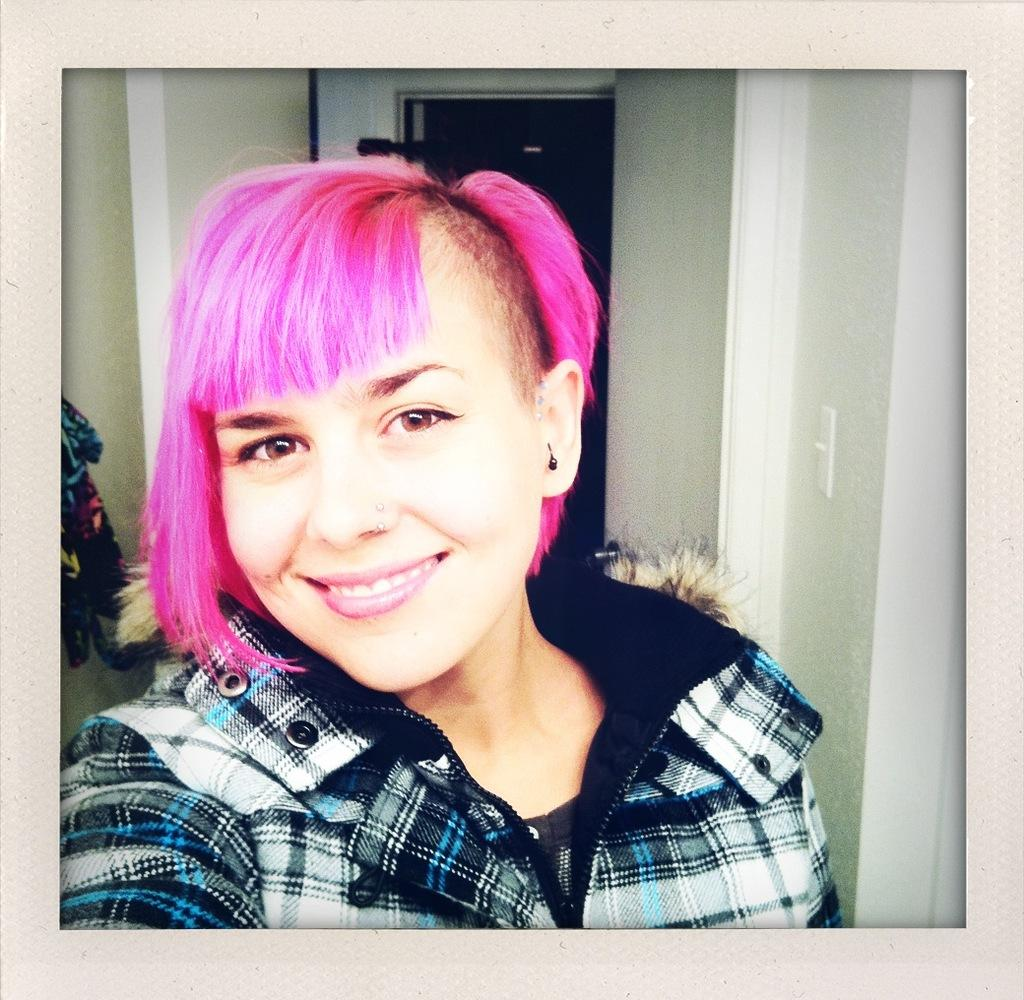Who is in the image? There is a woman in the image. What is the woman doing in the image? The woman is smiling in the image. What color is the woman's hair? The woman's hair is pink. What can be seen in the background of the image? There is a wall in the background of the image. What is on the left side of the image? There is a cloth on the left side of the image. What type of oatmeal is being served on the hydrant in the image? There is no oatmeal or hydrant present in the image; it features a woman with pink hair who is smiling. 